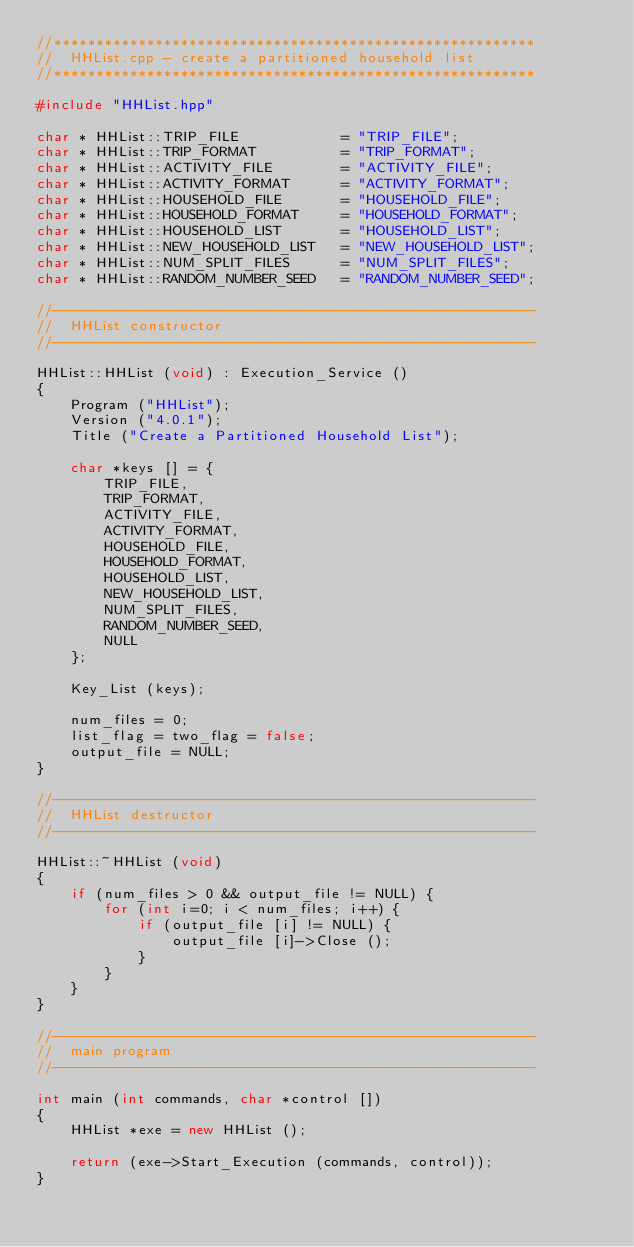Convert code to text. <code><loc_0><loc_0><loc_500><loc_500><_C++_>//*********************************************************
//	HHList.cpp - create a partitioned household list
//*********************************************************

#include "HHList.hpp"

char * HHList::TRIP_FILE			= "TRIP_FILE";
char * HHList::TRIP_FORMAT			= "TRIP_FORMAT";
char * HHList::ACTIVITY_FILE		= "ACTIVITY_FILE";
char * HHList::ACTIVITY_FORMAT		= "ACTIVITY_FORMAT";
char * HHList::HOUSEHOLD_FILE       = "HOUSEHOLD_FILE";
char * HHList::HOUSEHOLD_FORMAT		= "HOUSEHOLD_FORMAT";
char * HHList::HOUSEHOLD_LIST		= "HOUSEHOLD_LIST";
char * HHList::NEW_HOUSEHOLD_LIST	= "NEW_HOUSEHOLD_LIST";
char * HHList::NUM_SPLIT_FILES		= "NUM_SPLIT_FILES";
char * HHList::RANDOM_NUMBER_SEED	= "RANDOM_NUMBER_SEED";

//---------------------------------------------------------
//	HHList constructor
//---------------------------------------------------------

HHList::HHList (void) : Execution_Service ()
{
	Program ("HHList");
	Version ("4.0.1");
	Title ("Create a Partitioned Household List");

	char *keys [] = {
		TRIP_FILE,
		TRIP_FORMAT,
		ACTIVITY_FILE,
		ACTIVITY_FORMAT,
		HOUSEHOLD_FILE,
		HOUSEHOLD_FORMAT,
		HOUSEHOLD_LIST,
		NEW_HOUSEHOLD_LIST,
		NUM_SPLIT_FILES,
		RANDOM_NUMBER_SEED,
		NULL
	};

	Key_List (keys);

	num_files = 0;
	list_flag = two_flag = false;
	output_file = NULL;
}

//---------------------------------------------------------
//	HHList destructor
//---------------------------------------------------------

HHList::~HHList (void)
{
	if (num_files > 0 && output_file != NULL) {
		for (int i=0; i < num_files; i++) {
			if (output_file [i] != NULL) {
				output_file [i]->Close ();
			}
		}
	}
}

//---------------------------------------------------------
//	main program
//---------------------------------------------------------

int main (int commands, char *control [])
{
	HHList *exe = new HHList ();

	return (exe->Start_Execution (commands, control));
}
</code> 